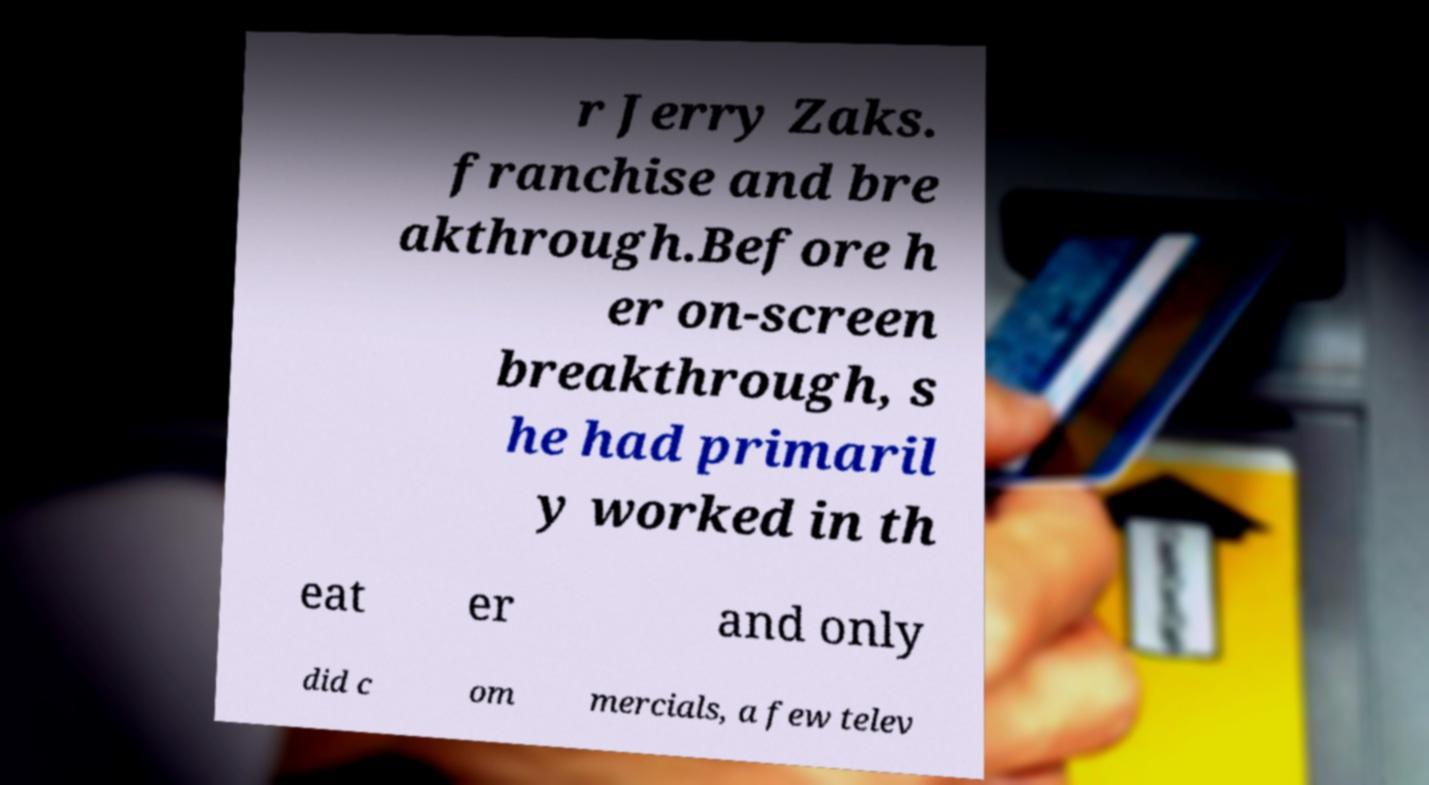There's text embedded in this image that I need extracted. Can you transcribe it verbatim? r Jerry Zaks. franchise and bre akthrough.Before h er on-screen breakthrough, s he had primaril y worked in th eat er and only did c om mercials, a few telev 